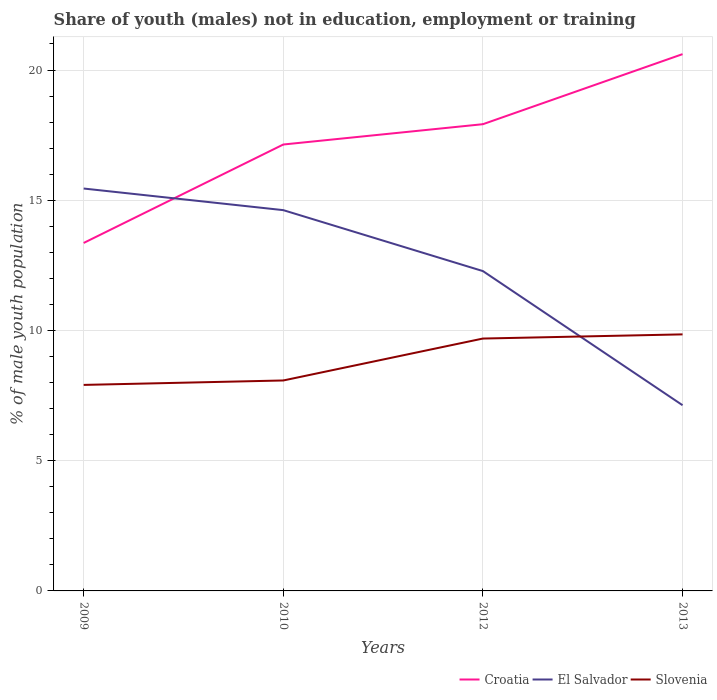How many different coloured lines are there?
Your answer should be compact. 3. Is the number of lines equal to the number of legend labels?
Make the answer very short. Yes. Across all years, what is the maximum percentage of unemployed males population in in El Salvador?
Offer a very short reply. 7.13. In which year was the percentage of unemployed males population in in Slovenia maximum?
Offer a terse response. 2009. What is the total percentage of unemployed males population in in El Salvador in the graph?
Provide a short and direct response. 2.34. What is the difference between the highest and the second highest percentage of unemployed males population in in El Salvador?
Provide a short and direct response. 8.32. How many years are there in the graph?
Your answer should be very brief. 4. Are the values on the major ticks of Y-axis written in scientific E-notation?
Your answer should be very brief. No. Does the graph contain any zero values?
Offer a terse response. No. Where does the legend appear in the graph?
Provide a succinct answer. Bottom right. How many legend labels are there?
Your answer should be very brief. 3. What is the title of the graph?
Your answer should be compact. Share of youth (males) not in education, employment or training. What is the label or title of the Y-axis?
Give a very brief answer. % of male youth population. What is the % of male youth population of Croatia in 2009?
Keep it short and to the point. 13.36. What is the % of male youth population in El Salvador in 2009?
Ensure brevity in your answer.  15.45. What is the % of male youth population of Slovenia in 2009?
Offer a very short reply. 7.91. What is the % of male youth population in Croatia in 2010?
Your answer should be very brief. 17.14. What is the % of male youth population in El Salvador in 2010?
Your answer should be very brief. 14.62. What is the % of male youth population of Slovenia in 2010?
Offer a very short reply. 8.08. What is the % of male youth population in Croatia in 2012?
Your answer should be very brief. 17.92. What is the % of male youth population in El Salvador in 2012?
Make the answer very short. 12.28. What is the % of male youth population of Slovenia in 2012?
Make the answer very short. 9.69. What is the % of male youth population in Croatia in 2013?
Provide a short and direct response. 20.61. What is the % of male youth population of El Salvador in 2013?
Your response must be concise. 7.13. What is the % of male youth population in Slovenia in 2013?
Ensure brevity in your answer.  9.85. Across all years, what is the maximum % of male youth population of Croatia?
Offer a terse response. 20.61. Across all years, what is the maximum % of male youth population in El Salvador?
Your answer should be compact. 15.45. Across all years, what is the maximum % of male youth population in Slovenia?
Keep it short and to the point. 9.85. Across all years, what is the minimum % of male youth population in Croatia?
Your response must be concise. 13.36. Across all years, what is the minimum % of male youth population of El Salvador?
Ensure brevity in your answer.  7.13. Across all years, what is the minimum % of male youth population of Slovenia?
Your answer should be very brief. 7.91. What is the total % of male youth population in Croatia in the graph?
Provide a short and direct response. 69.03. What is the total % of male youth population of El Salvador in the graph?
Provide a short and direct response. 49.48. What is the total % of male youth population of Slovenia in the graph?
Ensure brevity in your answer.  35.53. What is the difference between the % of male youth population in Croatia in 2009 and that in 2010?
Offer a very short reply. -3.78. What is the difference between the % of male youth population of El Salvador in 2009 and that in 2010?
Make the answer very short. 0.83. What is the difference between the % of male youth population in Slovenia in 2009 and that in 2010?
Make the answer very short. -0.17. What is the difference between the % of male youth population of Croatia in 2009 and that in 2012?
Make the answer very short. -4.56. What is the difference between the % of male youth population in El Salvador in 2009 and that in 2012?
Offer a very short reply. 3.17. What is the difference between the % of male youth population in Slovenia in 2009 and that in 2012?
Your response must be concise. -1.78. What is the difference between the % of male youth population in Croatia in 2009 and that in 2013?
Provide a succinct answer. -7.25. What is the difference between the % of male youth population of El Salvador in 2009 and that in 2013?
Ensure brevity in your answer.  8.32. What is the difference between the % of male youth population in Slovenia in 2009 and that in 2013?
Keep it short and to the point. -1.94. What is the difference between the % of male youth population of Croatia in 2010 and that in 2012?
Provide a succinct answer. -0.78. What is the difference between the % of male youth population of El Salvador in 2010 and that in 2012?
Provide a short and direct response. 2.34. What is the difference between the % of male youth population in Slovenia in 2010 and that in 2012?
Ensure brevity in your answer.  -1.61. What is the difference between the % of male youth population in Croatia in 2010 and that in 2013?
Give a very brief answer. -3.47. What is the difference between the % of male youth population in El Salvador in 2010 and that in 2013?
Your answer should be very brief. 7.49. What is the difference between the % of male youth population of Slovenia in 2010 and that in 2013?
Your answer should be very brief. -1.77. What is the difference between the % of male youth population of Croatia in 2012 and that in 2013?
Keep it short and to the point. -2.69. What is the difference between the % of male youth population in El Salvador in 2012 and that in 2013?
Make the answer very short. 5.15. What is the difference between the % of male youth population of Slovenia in 2012 and that in 2013?
Offer a very short reply. -0.16. What is the difference between the % of male youth population of Croatia in 2009 and the % of male youth population of El Salvador in 2010?
Ensure brevity in your answer.  -1.26. What is the difference between the % of male youth population of Croatia in 2009 and the % of male youth population of Slovenia in 2010?
Your answer should be compact. 5.28. What is the difference between the % of male youth population of El Salvador in 2009 and the % of male youth population of Slovenia in 2010?
Your answer should be very brief. 7.37. What is the difference between the % of male youth population in Croatia in 2009 and the % of male youth population in El Salvador in 2012?
Ensure brevity in your answer.  1.08. What is the difference between the % of male youth population of Croatia in 2009 and the % of male youth population of Slovenia in 2012?
Your answer should be very brief. 3.67. What is the difference between the % of male youth population of El Salvador in 2009 and the % of male youth population of Slovenia in 2012?
Your answer should be compact. 5.76. What is the difference between the % of male youth population of Croatia in 2009 and the % of male youth population of El Salvador in 2013?
Provide a succinct answer. 6.23. What is the difference between the % of male youth population of Croatia in 2009 and the % of male youth population of Slovenia in 2013?
Offer a terse response. 3.51. What is the difference between the % of male youth population in Croatia in 2010 and the % of male youth population in El Salvador in 2012?
Your answer should be compact. 4.86. What is the difference between the % of male youth population of Croatia in 2010 and the % of male youth population of Slovenia in 2012?
Keep it short and to the point. 7.45. What is the difference between the % of male youth population of El Salvador in 2010 and the % of male youth population of Slovenia in 2012?
Your response must be concise. 4.93. What is the difference between the % of male youth population of Croatia in 2010 and the % of male youth population of El Salvador in 2013?
Offer a very short reply. 10.01. What is the difference between the % of male youth population in Croatia in 2010 and the % of male youth population in Slovenia in 2013?
Your answer should be very brief. 7.29. What is the difference between the % of male youth population of El Salvador in 2010 and the % of male youth population of Slovenia in 2013?
Provide a succinct answer. 4.77. What is the difference between the % of male youth population of Croatia in 2012 and the % of male youth population of El Salvador in 2013?
Your answer should be compact. 10.79. What is the difference between the % of male youth population of Croatia in 2012 and the % of male youth population of Slovenia in 2013?
Your answer should be very brief. 8.07. What is the difference between the % of male youth population of El Salvador in 2012 and the % of male youth population of Slovenia in 2013?
Provide a succinct answer. 2.43. What is the average % of male youth population of Croatia per year?
Ensure brevity in your answer.  17.26. What is the average % of male youth population of El Salvador per year?
Your response must be concise. 12.37. What is the average % of male youth population in Slovenia per year?
Keep it short and to the point. 8.88. In the year 2009, what is the difference between the % of male youth population in Croatia and % of male youth population in El Salvador?
Your answer should be compact. -2.09. In the year 2009, what is the difference between the % of male youth population of Croatia and % of male youth population of Slovenia?
Offer a terse response. 5.45. In the year 2009, what is the difference between the % of male youth population of El Salvador and % of male youth population of Slovenia?
Ensure brevity in your answer.  7.54. In the year 2010, what is the difference between the % of male youth population in Croatia and % of male youth population in El Salvador?
Offer a terse response. 2.52. In the year 2010, what is the difference between the % of male youth population of Croatia and % of male youth population of Slovenia?
Offer a very short reply. 9.06. In the year 2010, what is the difference between the % of male youth population of El Salvador and % of male youth population of Slovenia?
Your answer should be very brief. 6.54. In the year 2012, what is the difference between the % of male youth population in Croatia and % of male youth population in El Salvador?
Give a very brief answer. 5.64. In the year 2012, what is the difference between the % of male youth population in Croatia and % of male youth population in Slovenia?
Ensure brevity in your answer.  8.23. In the year 2012, what is the difference between the % of male youth population of El Salvador and % of male youth population of Slovenia?
Offer a very short reply. 2.59. In the year 2013, what is the difference between the % of male youth population of Croatia and % of male youth population of El Salvador?
Give a very brief answer. 13.48. In the year 2013, what is the difference between the % of male youth population in Croatia and % of male youth population in Slovenia?
Make the answer very short. 10.76. In the year 2013, what is the difference between the % of male youth population in El Salvador and % of male youth population in Slovenia?
Offer a terse response. -2.72. What is the ratio of the % of male youth population in Croatia in 2009 to that in 2010?
Keep it short and to the point. 0.78. What is the ratio of the % of male youth population in El Salvador in 2009 to that in 2010?
Offer a very short reply. 1.06. What is the ratio of the % of male youth population in Slovenia in 2009 to that in 2010?
Your response must be concise. 0.98. What is the ratio of the % of male youth population of Croatia in 2009 to that in 2012?
Provide a short and direct response. 0.75. What is the ratio of the % of male youth population of El Salvador in 2009 to that in 2012?
Provide a short and direct response. 1.26. What is the ratio of the % of male youth population of Slovenia in 2009 to that in 2012?
Offer a very short reply. 0.82. What is the ratio of the % of male youth population of Croatia in 2009 to that in 2013?
Your response must be concise. 0.65. What is the ratio of the % of male youth population in El Salvador in 2009 to that in 2013?
Your response must be concise. 2.17. What is the ratio of the % of male youth population in Slovenia in 2009 to that in 2013?
Give a very brief answer. 0.8. What is the ratio of the % of male youth population in Croatia in 2010 to that in 2012?
Offer a very short reply. 0.96. What is the ratio of the % of male youth population in El Salvador in 2010 to that in 2012?
Provide a short and direct response. 1.19. What is the ratio of the % of male youth population in Slovenia in 2010 to that in 2012?
Offer a very short reply. 0.83. What is the ratio of the % of male youth population in Croatia in 2010 to that in 2013?
Provide a short and direct response. 0.83. What is the ratio of the % of male youth population of El Salvador in 2010 to that in 2013?
Keep it short and to the point. 2.05. What is the ratio of the % of male youth population in Slovenia in 2010 to that in 2013?
Ensure brevity in your answer.  0.82. What is the ratio of the % of male youth population in Croatia in 2012 to that in 2013?
Your response must be concise. 0.87. What is the ratio of the % of male youth population in El Salvador in 2012 to that in 2013?
Your answer should be compact. 1.72. What is the ratio of the % of male youth population of Slovenia in 2012 to that in 2013?
Keep it short and to the point. 0.98. What is the difference between the highest and the second highest % of male youth population in Croatia?
Offer a very short reply. 2.69. What is the difference between the highest and the second highest % of male youth population in El Salvador?
Keep it short and to the point. 0.83. What is the difference between the highest and the second highest % of male youth population of Slovenia?
Offer a terse response. 0.16. What is the difference between the highest and the lowest % of male youth population in Croatia?
Make the answer very short. 7.25. What is the difference between the highest and the lowest % of male youth population of El Salvador?
Your answer should be compact. 8.32. What is the difference between the highest and the lowest % of male youth population of Slovenia?
Your response must be concise. 1.94. 